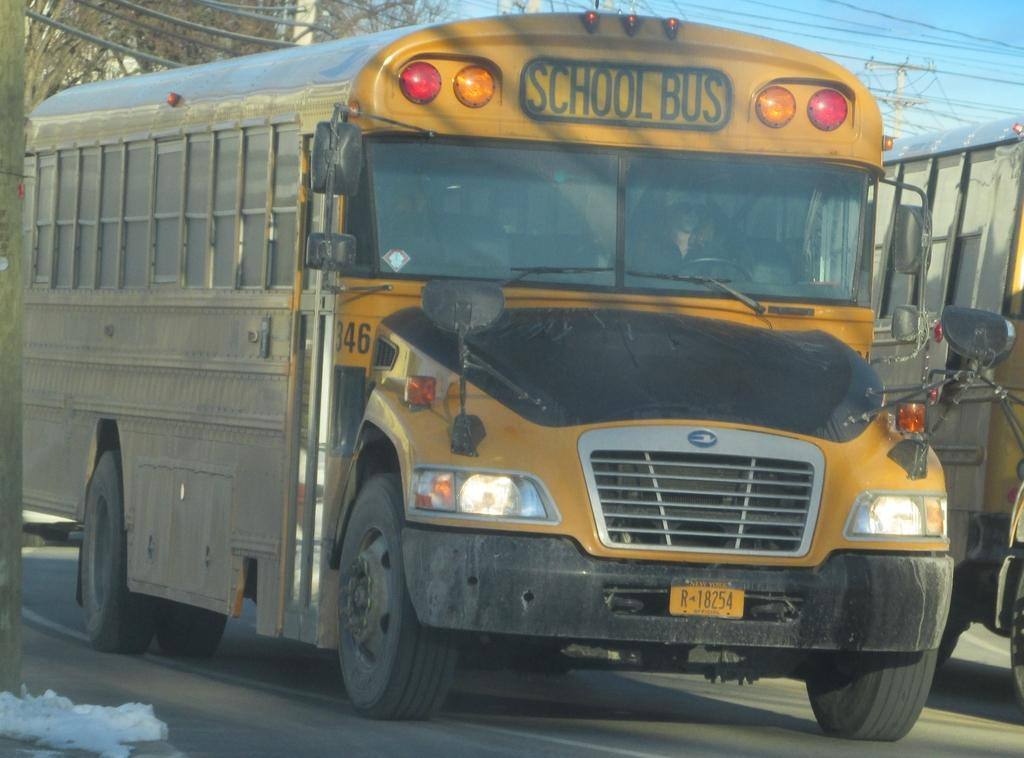What can be seen on the road in the image? There are vehicles on the road in the image. What structures are visible in the background of the image? There are current poles and trees in the background of the image. What is visible in the sky in the image? The sky is visible in the background of the image. What is located on the left side of the image? There is a pole on the left side of the image. Can you see a yak pulling a cart in the image? There is no yak or cart present in the image. How many zippers are visible on the vehicles in the image? There are no zippers on the vehicles in the image, as vehicles do not have zippers. 